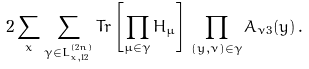<formula> <loc_0><loc_0><loc_500><loc_500>2 \sum _ { x } \sum _ { \gamma \in L ^ { ( 2 n ) } _ { x , 1 2 } } T r \left [ \prod _ { \mu \in \gamma } H _ { \mu } \right ] \, \prod _ { ( y , \nu ) \in \gamma } A _ { \nu 3 } ( y ) \, .</formula> 